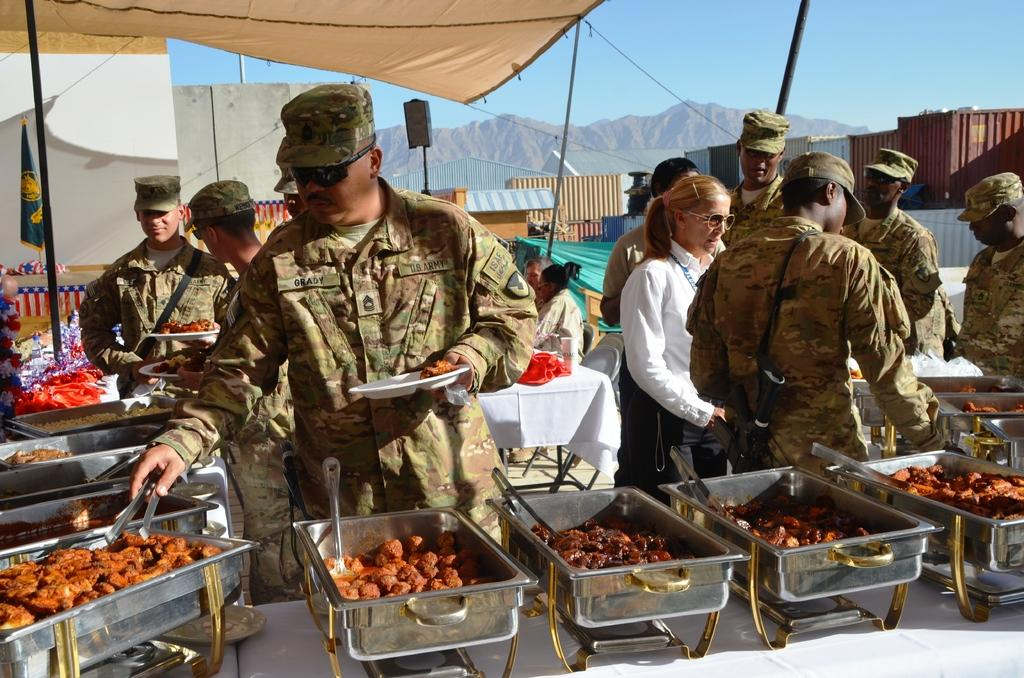What are the men in the image wearing? The men in the image are wearing camouflage dress. What are the men doing with the food from the bowls? The men are keeping food from bowls on a table. What can be seen in the background of the image? Hills, buildings, and the sky are visible in the background of the image. How much payment is required to access the wave in the image? There is no wave present in the image, so no payment is required. 